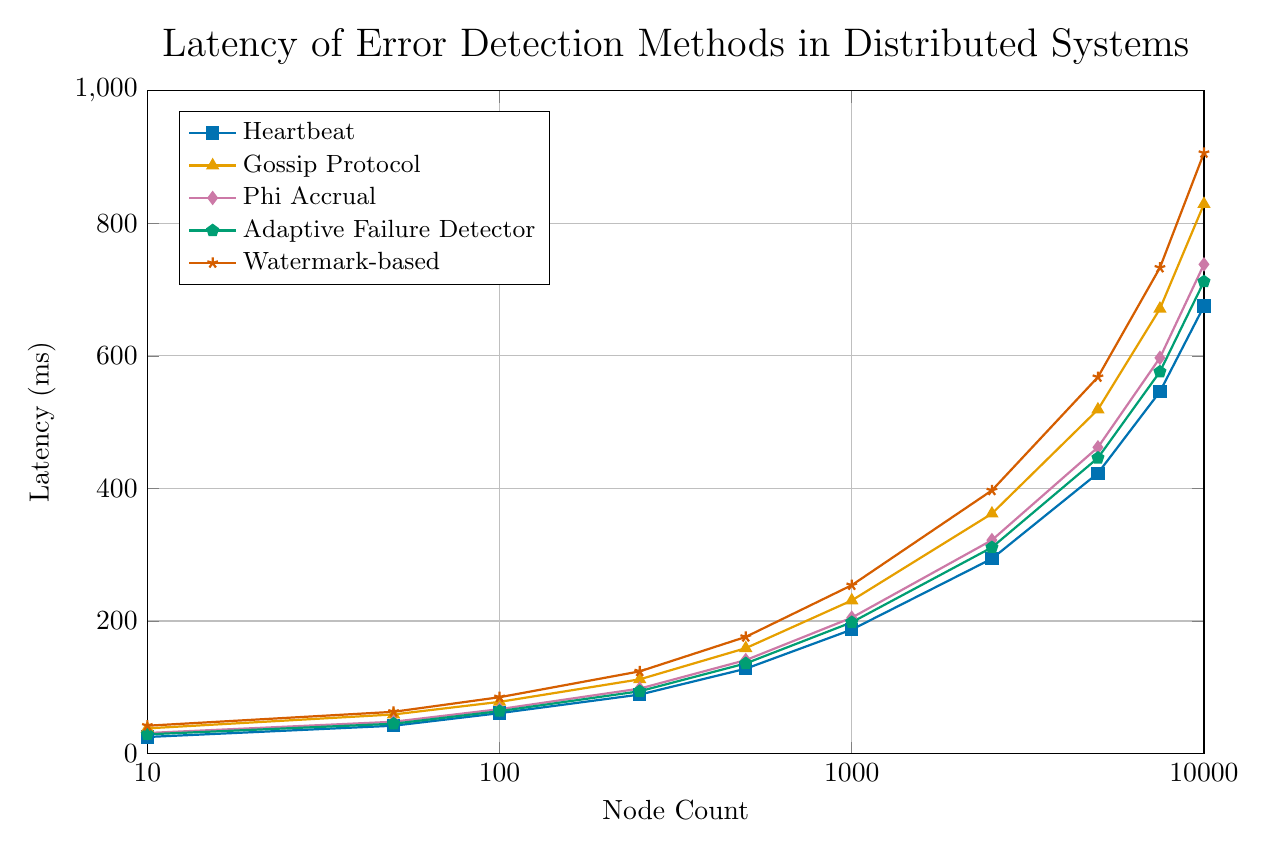What is the latency of the Heartbeat method when the node count is 2500? Locate the Heartbeat method (the line with data points labeled "Heartbeat") and find the corresponding value on the y-axis when the node count on the x-axis is 2500.
Answer: 294 ms Among the given methods, which one has the highest latency for a node count of 1000? Look for the highest data point on the y-axis for the node count of 1000 across all the lines. The highest point corresponds to the "Watermark-based" method.
Answer: Watermark-based Which method shows the steepest increase in latency between node counts of 5000 and 7500? Calculate the difference in latency for each method between node counts of 5000 and 7500. Compare these differences to identify the greatest one, which is for the "Watermark-based" method (733 - 568 = 165).
Answer: Watermark-based For the "Gossip Protocol" method, what is the average latency of the latencies corresponding to node counts of 10, 100, and 1000? Identify the data points for the "Gossip Protocol" method at node counts of 10, 100, and 1000, which are 38, 78, and 231 ms respectively. The average is calculated as (38 + 78 + 231) / 3 = 115.67 ms.
Answer: 115.67 ms Compare the latency of Phi Accrual to Adaptive Failure Detector at node count of 10. Which one is lower and by how much? Locate the latencies of Phi Accrual (31 ms) and Adaptive Failure Detector (29 ms) at the node count of 10. Subtract the smaller latency from the larger one: 31 - 29 = 2 ms.
Answer: Adaptive Failure Detector is lower by 2 ms At what node count does the latency of the Heartbeat method exceed 100 ms? Find the data points for the Heartbeat method and identify the smallest node count where the latency surpasses 100 ms. This occurs between nodes 250 and 500. By finding the exact value, we see at node 500, it's 128 ms.
Answer: 500 What is the difference in latency between the "Adaptive Failure Detector" method and the "Phi Accrual" method at a node count of 10,000? Identify the latencies for both methods at a node count of 10,000 from the figure. For "Adaptive Failure Detector," it's 712 ms, and for "Phi Accrual," it’s 738 ms. Calculate the difference as 738 - 712 = 26 ms.
Answer: 26 ms Which method consistently has the lowest latency across all node counts? Compare the values of all methods at each node count point. "Heartbeat" shows consistently lower latency than others over the entire range.
Answer: Heartbeat For the Watermark-based method, calculate the percentage increase in latency from 1000 nodes to 10000 nodes. Identify the latencies for the Watermark-based method at 1000 nodes (254 ms) and 10000 nodes (906 ms). Calculate the percentage increase: ((906 - 254) / 254) * 100 = 256.69%.
Answer: 256.69% By how much does the latency of the Heartbeat method change when the node count increases from 50 to 5000? Look at the latencies of the Heartbeat method at 50 nodes (42 ms) and 5000 nodes (423 ms). Subtract the smaller latency from the larger one: 423 - 42 = 381 ms.
Answer: 381 ms 